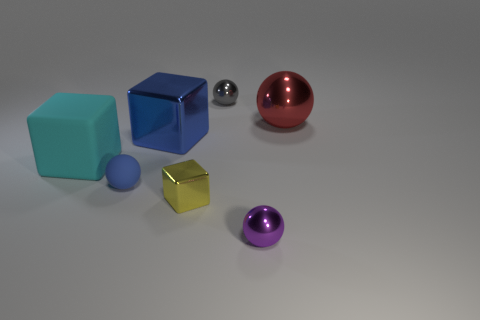What number of large shiny blocks are in front of the cyan cube?
Give a very brief answer. 0. Is the number of blue things in front of the large cyan rubber block less than the number of blue metallic things?
Your answer should be compact. No. The small block has what color?
Provide a short and direct response. Yellow. Do the matte thing to the right of the big rubber block and the tiny metal cube have the same color?
Ensure brevity in your answer.  No. There is a big thing that is the same shape as the tiny blue thing; what is its color?
Provide a short and direct response. Red. How many small objects are metallic blocks or gray balls?
Provide a short and direct response. 2. How big is the shiny sphere that is behind the big metal ball?
Provide a succinct answer. Small. Are there any other blocks of the same color as the large metallic block?
Provide a short and direct response. No. Does the rubber ball have the same color as the large sphere?
Provide a short and direct response. No. There is a big object that is the same color as the small matte object; what is its shape?
Provide a short and direct response. Cube. 